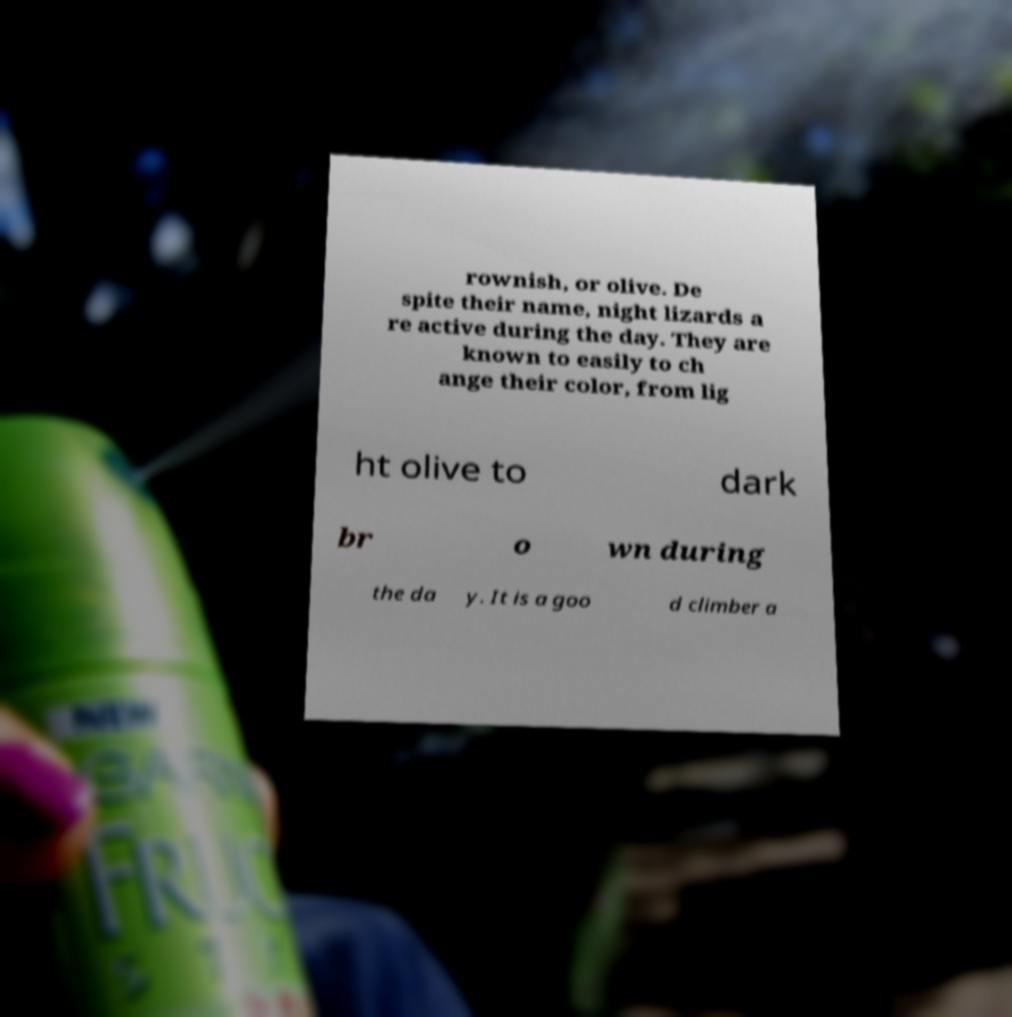Could you extract and type out the text from this image? rownish, or olive. De spite their name, night lizards a re active during the day. They are known to easily to ch ange their color, from lig ht olive to dark br o wn during the da y. It is a goo d climber a 